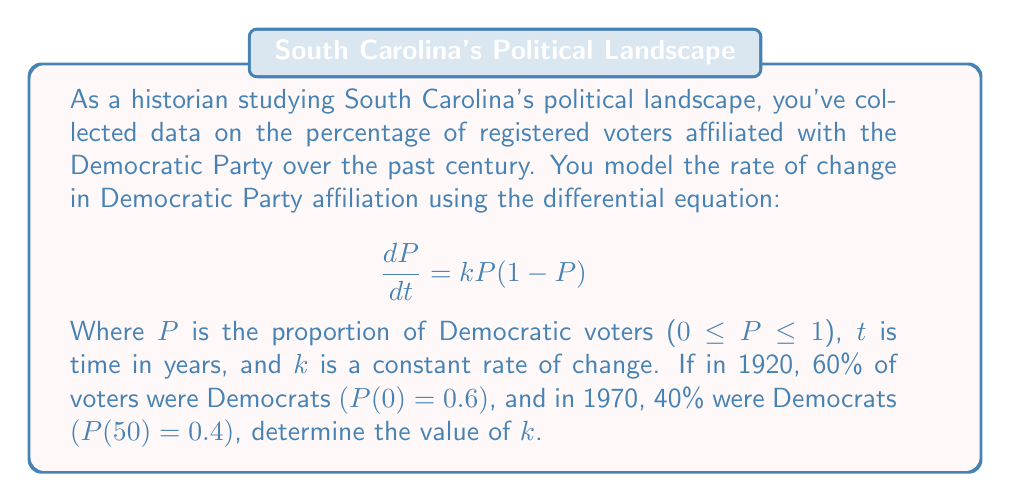Give your solution to this math problem. To solve this problem, we'll use the logistic differential equation solution and the given information:

1) The solution to the logistic differential equation $\frac{dP}{dt} = kP(1-P)$ is:

   $$P(t) = \frac{P_0}{P_0 + (1-P_0)e^{-kt}}$$

   Where $P_0$ is the initial proportion at $t=0$.

2) We're given that $P_0 = 0.6$ and $P(50) = 0.4$. Let's substitute these into the equation:

   $$0.4 = \frac{0.6}{0.6 + (1-0.6)e^{-50k}}$$

3) Simplify:
   $$0.4 = \frac{0.6}{0.6 + 0.4e^{-50k}}$$

4) Multiply both sides by the denominator:
   $$0.4(0.6 + 0.4e^{-50k}) = 0.6$$

5) Expand:
   $$0.24 + 0.16e^{-50k} = 0.6$$

6) Subtract 0.24 from both sides:
   $$0.16e^{-50k} = 0.36$$

7) Divide both sides by 0.16:
   $$e^{-50k} = 2.25$$

8) Take the natural log of both sides:
   $$-50k = \ln(2.25)$$

9) Solve for $k$:
   $$k = -\frac{\ln(2.25)}{50} \approx -0.0162$$

Therefore, the value of $k$ is approximately -0.0162.
Answer: $k \approx -0.0162$ 